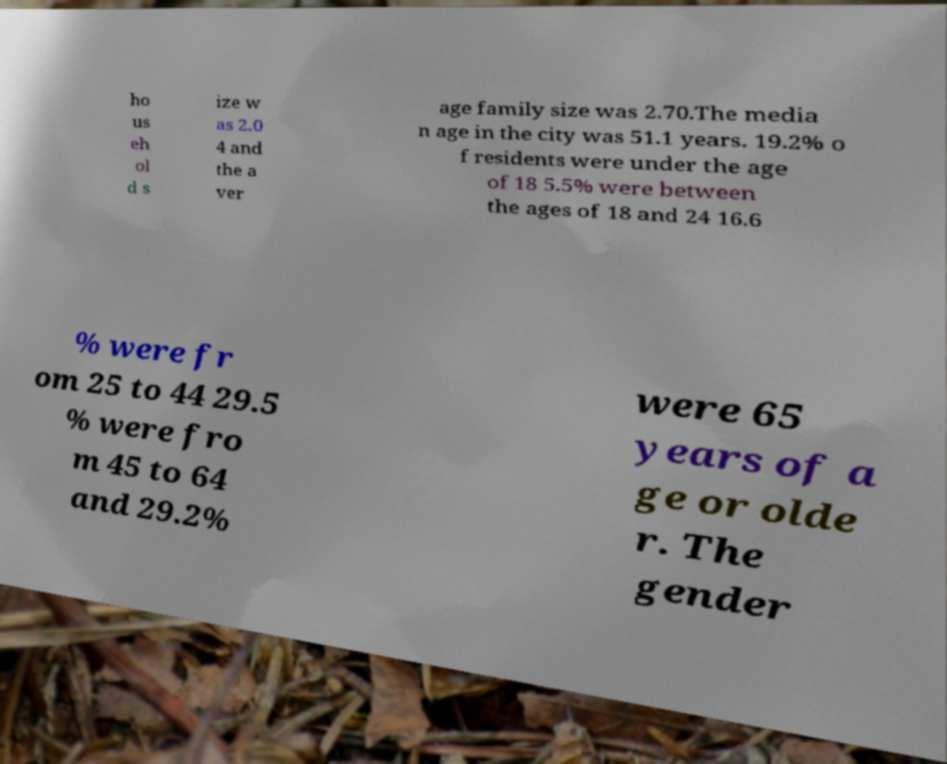Can you read and provide the text displayed in the image?This photo seems to have some interesting text. Can you extract and type it out for me? ho us eh ol d s ize w as 2.0 4 and the a ver age family size was 2.70.The media n age in the city was 51.1 years. 19.2% o f residents were under the age of 18 5.5% were between the ages of 18 and 24 16.6 % were fr om 25 to 44 29.5 % were fro m 45 to 64 and 29.2% were 65 years of a ge or olde r. The gender 